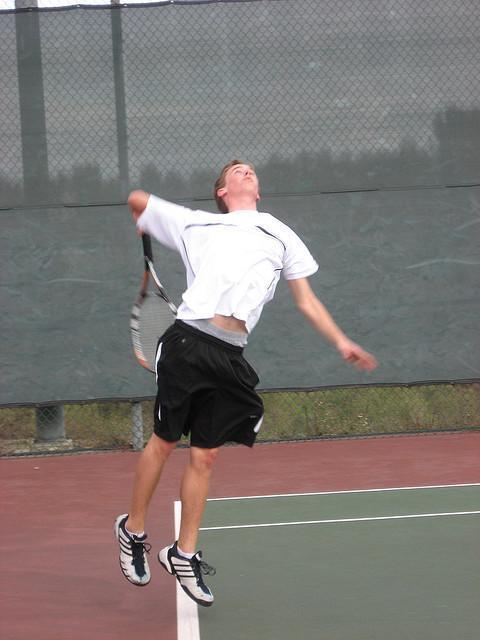How many tennis rackets are in the picture?
Give a very brief answer. 1. 